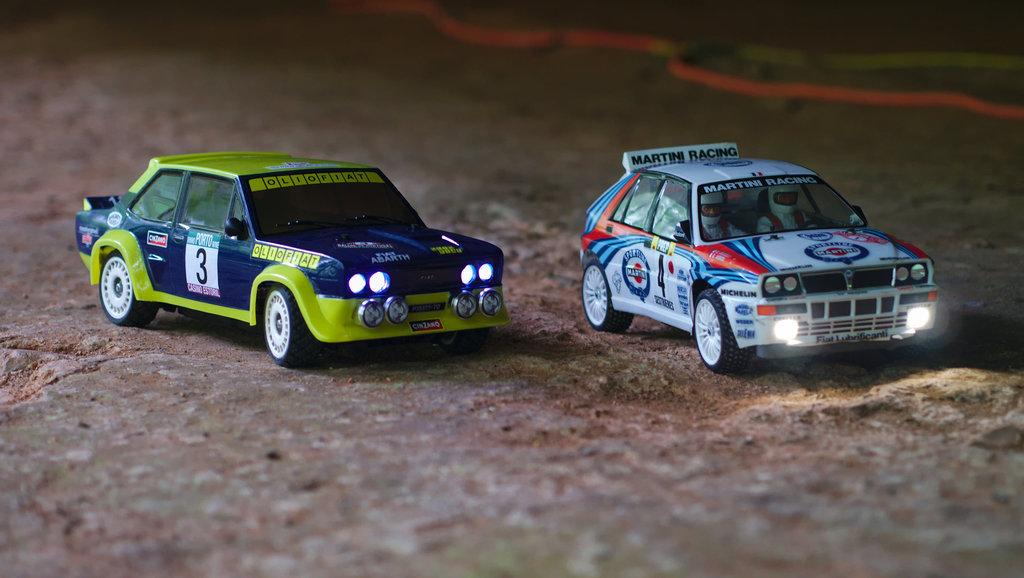What objects are present in the image? There are two toy cars in the image. Where are the toy cars located? The toy cars are on the ground. What type of rock is being used to dig with the spade in the image? There is no rock or spade present in the image; it only features two toy cars on the ground. 